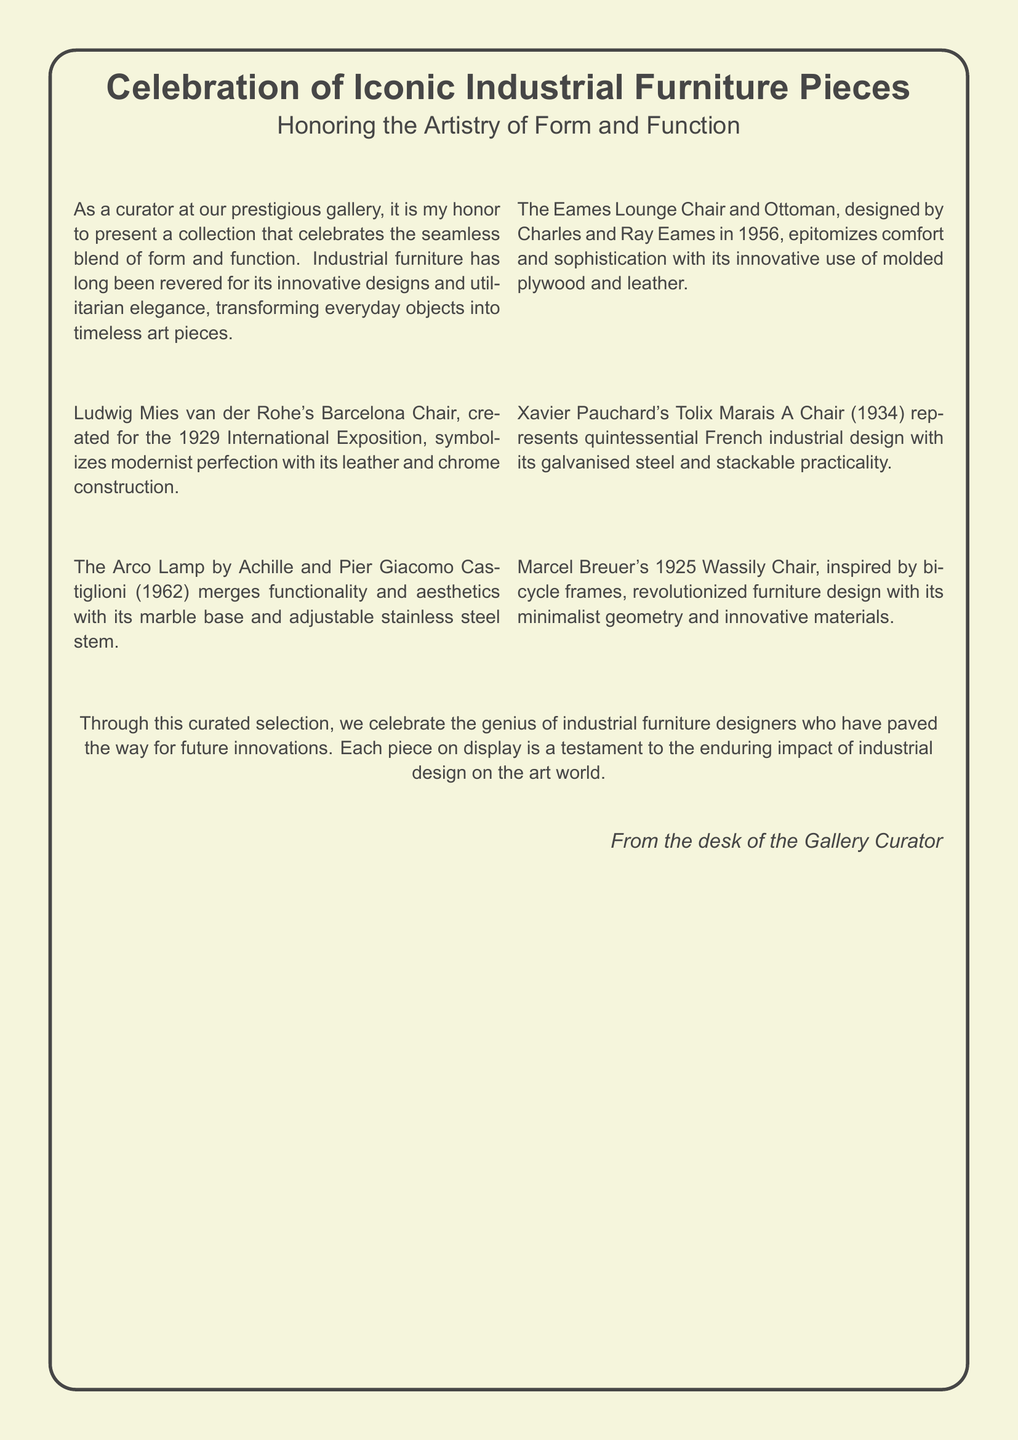what is the title of the celebration? The title of the celebration is included at the top of the document, which highlights the focus on iconic industrial furniture pieces.
Answer: Celebration of Iconic Industrial Furniture Pieces who designed the Eames Lounge Chair and Ottoman? The document provides the designer's name and the year it was created, indicating who is responsible for this iconic piece.
Answer: Charles and Ray Eames what year was the Barcelona Chair created? The document specifies the year in which the Barcelona Chair was produced, making it a crucial part of its historical context.
Answer: 1929 which material is used in the Arco Lamp's base? The description mentions the base material used in the Arco Lamp, which is a key feature of its functionality and design.
Answer: marble what innovative design feature does the Wassily Chair have? The document summarizes the unique inspiration behind the Wassily Chair, which involves specific modern elements.
Answer: minimalist geometry why are industrial furniture designs celebrated? The text elaborates on the reasons behind celebrating these pieces, which enhances understanding of their importance.
Answer: blend of form and function how many iconic furniture pieces are highlighted in the document? The document lists a total of furniture pieces featured, indicating the significance of the selection made for this celebration.
Answer: Six pieces what aesthetic characteristic does the Tolix Marais A Chair embody? The description indicates an essential feature of the Tolix chair that aligns with its design philosophy in industrial furniture.
Answer: stackable practicality 